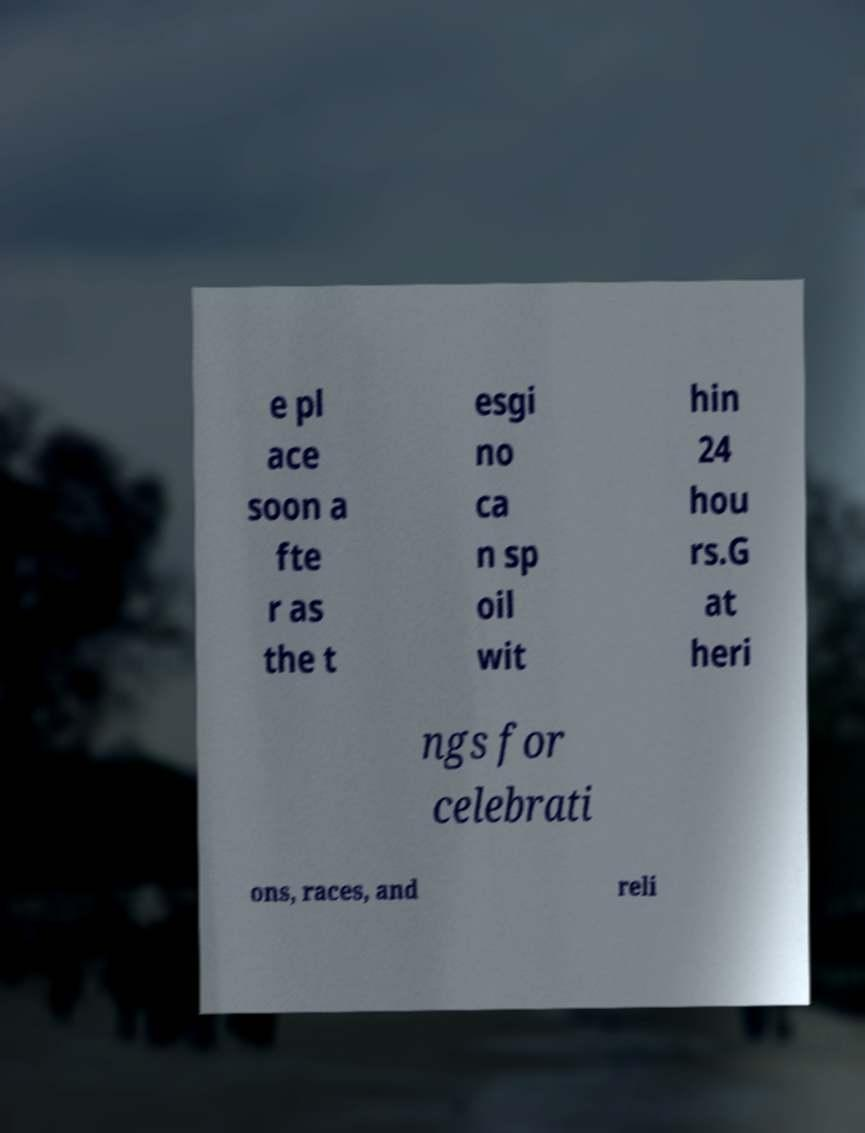For documentation purposes, I need the text within this image transcribed. Could you provide that? e pl ace soon a fte r as the t esgi no ca n sp oil wit hin 24 hou rs.G at heri ngs for celebrati ons, races, and reli 